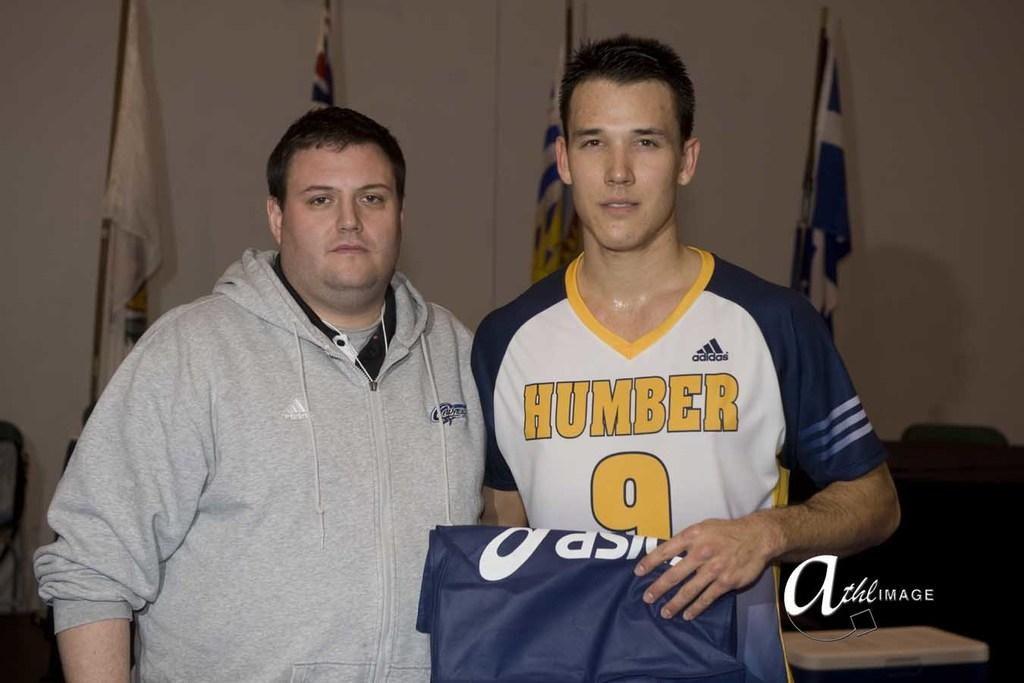<image>
Present a compact description of the photo's key features. 2 men one wearing a jersey that reads humber 9 